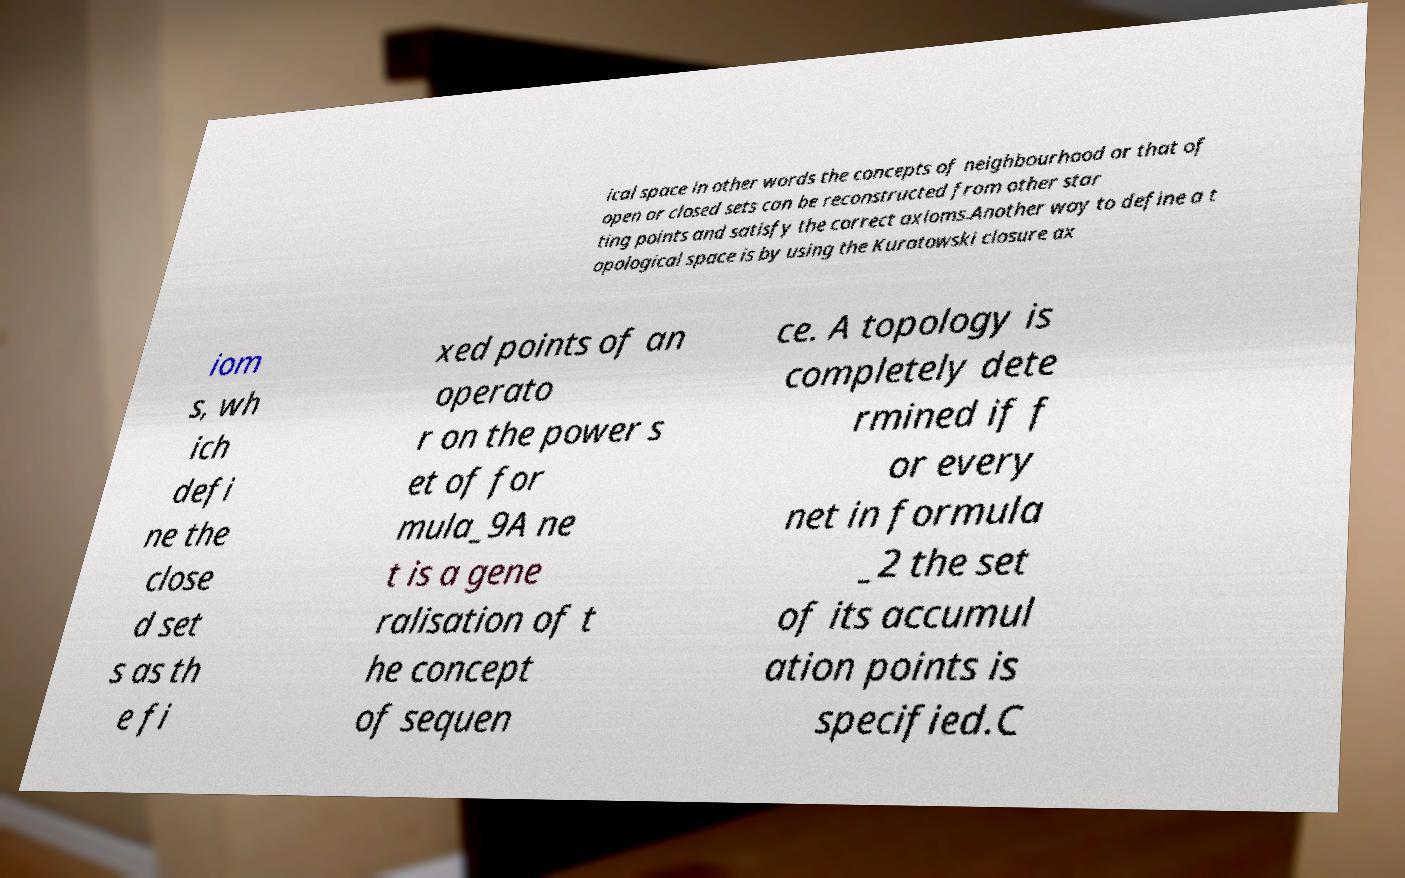What messages or text are displayed in this image? I need them in a readable, typed format. ical space in other words the concepts of neighbourhood or that of open or closed sets can be reconstructed from other star ting points and satisfy the correct axioms.Another way to define a t opological space is by using the Kuratowski closure ax iom s, wh ich defi ne the close d set s as th e fi xed points of an operato r on the power s et of for mula_9A ne t is a gene ralisation of t he concept of sequen ce. A topology is completely dete rmined if f or every net in formula _2 the set of its accumul ation points is specified.C 